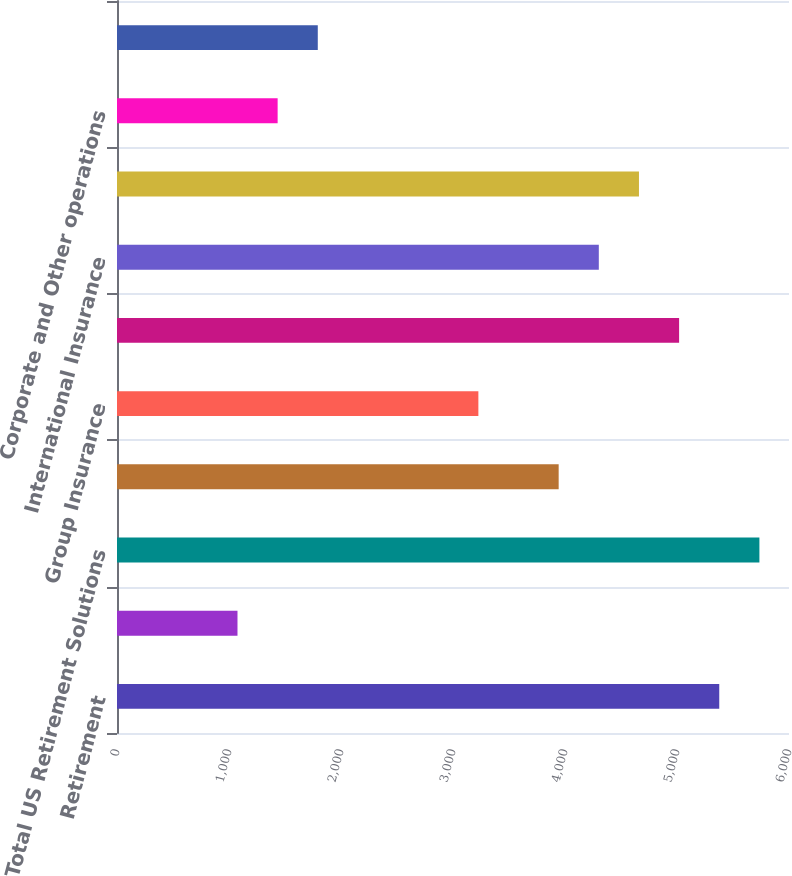<chart> <loc_0><loc_0><loc_500><loc_500><bar_chart><fcel>Retirement<fcel>Asset Management<fcel>Total US Retirement Solutions<fcel>Individual Life<fcel>Group Insurance<fcel>Total US Individual Life and<fcel>International Insurance<fcel>Total International Insurance<fcel>Corporate and Other operations<fcel>Total Corporate and Other<nl><fcel>5377.29<fcel>1075.77<fcel>5735.75<fcel>3943.45<fcel>3226.53<fcel>5018.83<fcel>4301.91<fcel>4660.37<fcel>1434.23<fcel>1792.69<nl></chart> 